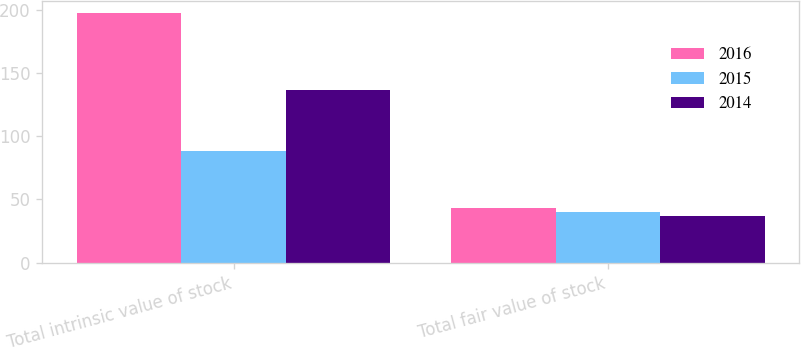Convert chart. <chart><loc_0><loc_0><loc_500><loc_500><stacked_bar_chart><ecel><fcel>Total intrinsic value of stock<fcel>Total fair value of stock<nl><fcel>2016<fcel>197.2<fcel>43.1<nl><fcel>2015<fcel>88.1<fcel>39.9<nl><fcel>2014<fcel>136.8<fcel>37.2<nl></chart> 